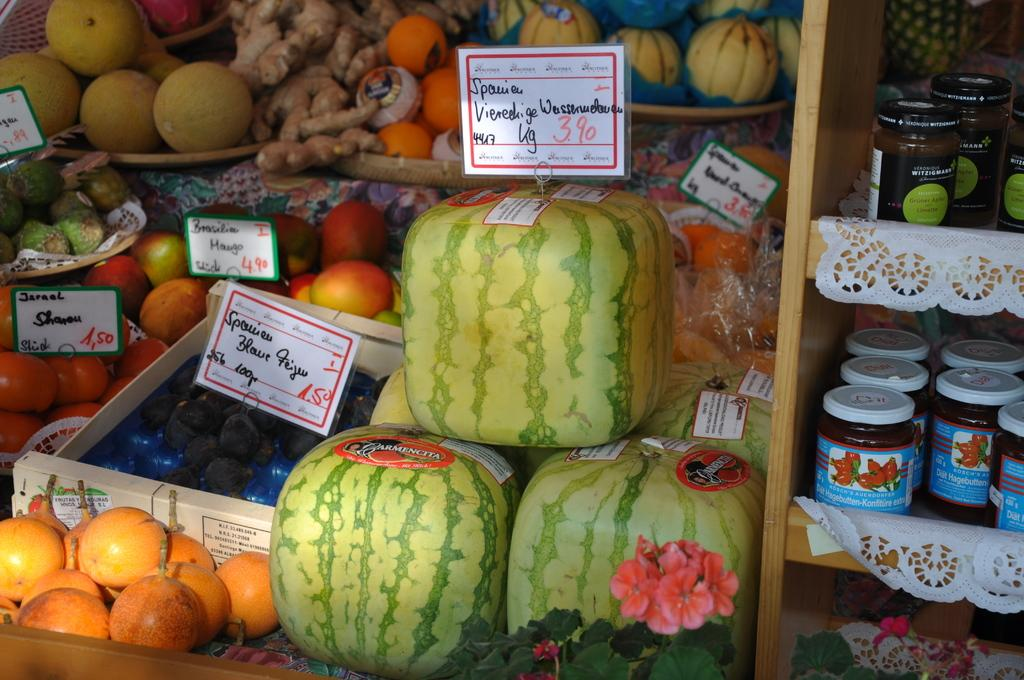What can be seen in the center of the image? There are racks in the center of the image. What items are present in the image that are related to paperwork? There are papers and baskets in the image. What type of decorations are visible in the image? There are banners in the image. What types of fruits can be seen in the image? There are watermelons, apples, and oranges in the image. Where is the faucet located in the image? There is no faucet present in the image. How does the image help improve memory? The image does not have any direct impact on memory improvement; it is a visual representation of various items. 